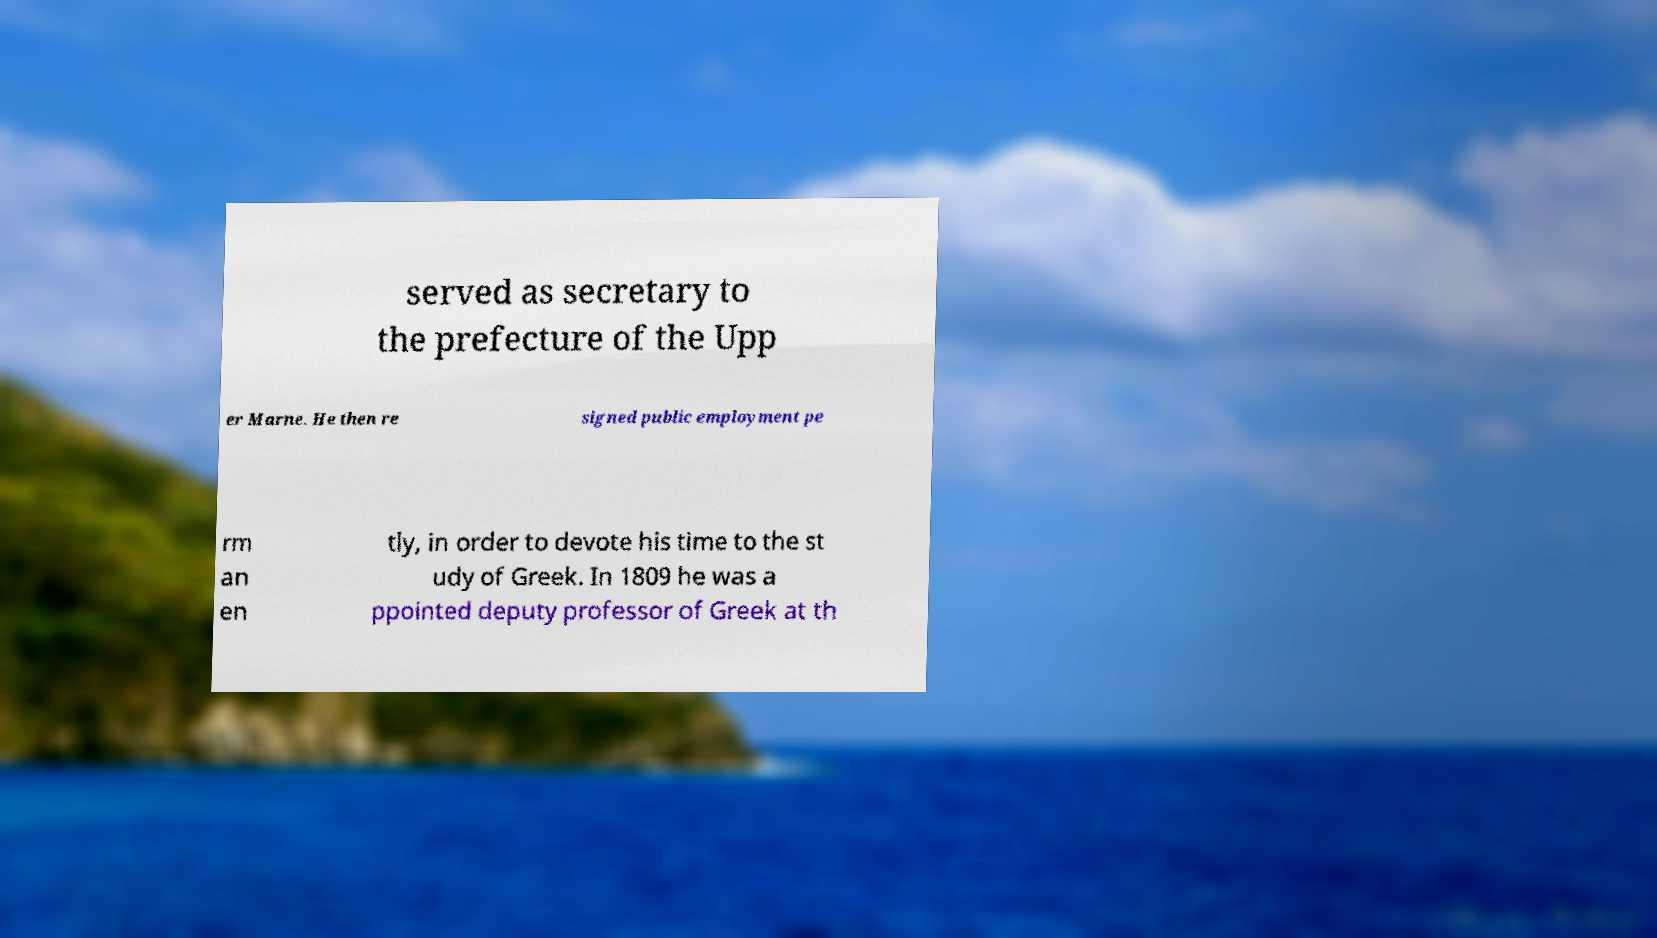What messages or text are displayed in this image? I need them in a readable, typed format. served as secretary to the prefecture of the Upp er Marne. He then re signed public employment pe rm an en tly, in order to devote his time to the st udy of Greek. In 1809 he was a ppointed deputy professor of Greek at th 